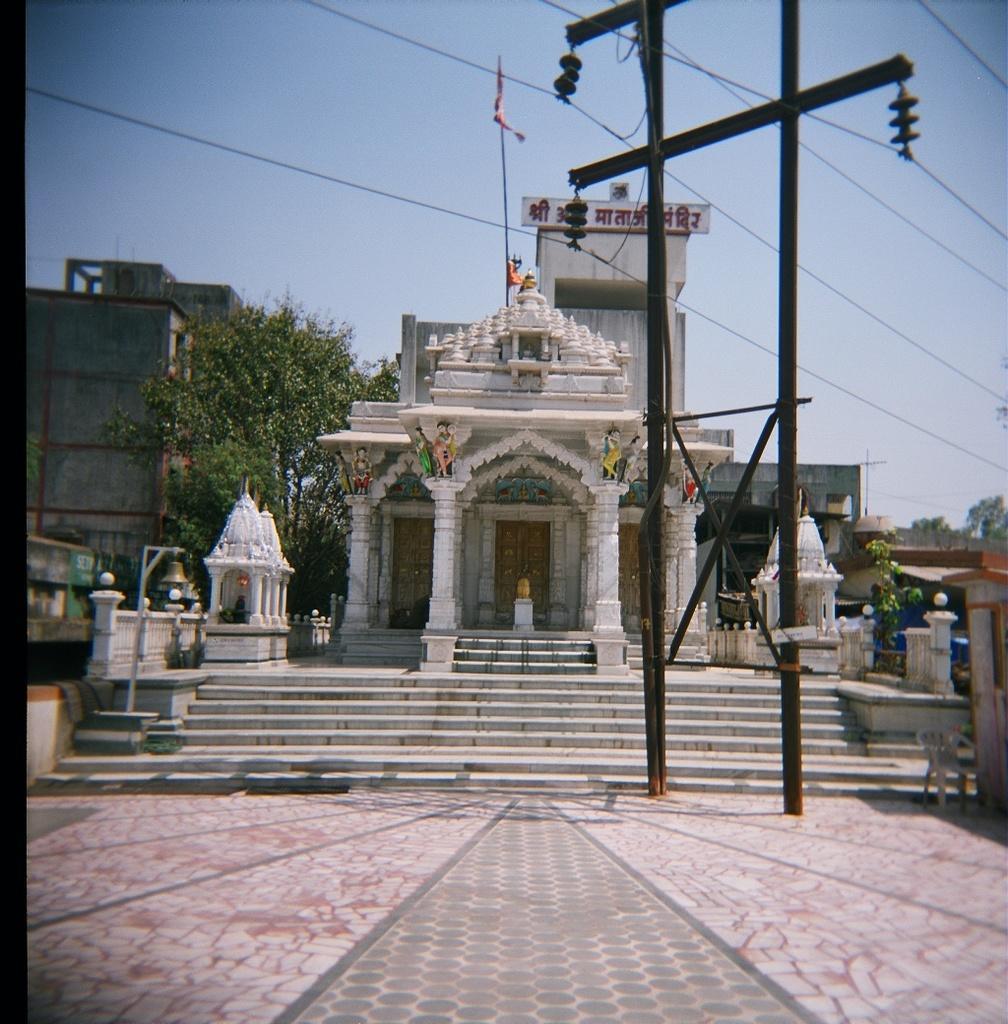Can you describe this image briefly? In this picture in the center there is one temple, and in the foreground there are two poles and some wires. In the background there are some buildings, pole and flags. In the center there are some stairs, at the bottom there is a walkway. On the right side there is one chair. 